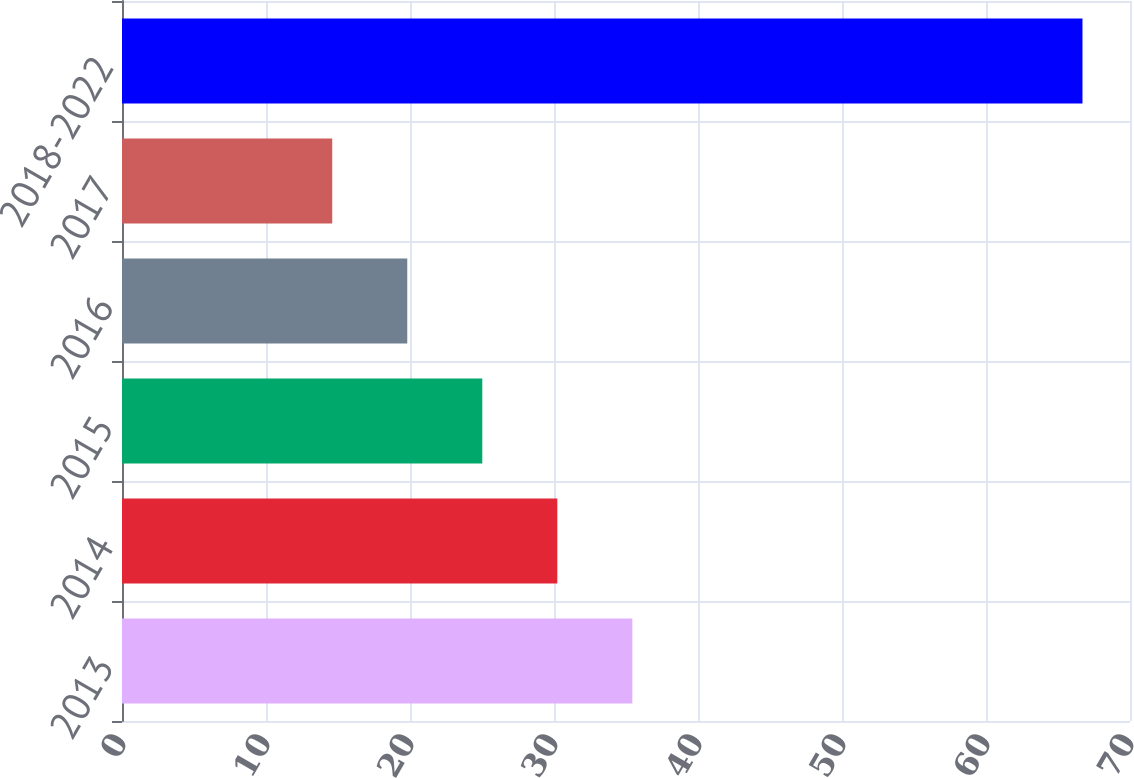Convert chart to OTSL. <chart><loc_0><loc_0><loc_500><loc_500><bar_chart><fcel>2013<fcel>2014<fcel>2015<fcel>2016<fcel>2017<fcel>2018-2022<nl><fcel>35.44<fcel>30.23<fcel>25.02<fcel>19.81<fcel>14.6<fcel>66.7<nl></chart> 